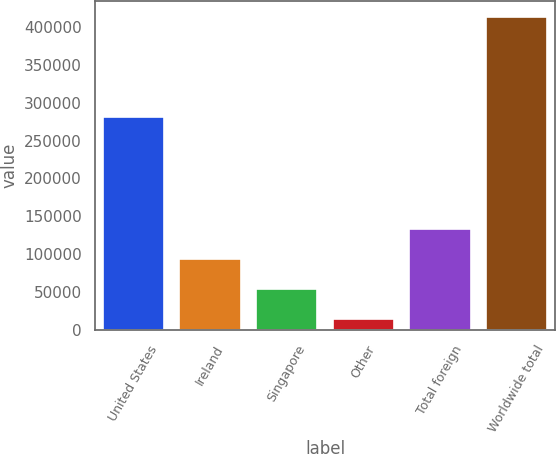<chart> <loc_0><loc_0><loc_500><loc_500><bar_chart><fcel>United States<fcel>Ireland<fcel>Singapore<fcel>Other<fcel>Total foreign<fcel>Worldwide total<nl><fcel>281517<fcel>93779.2<fcel>53872.1<fcel>13965<fcel>133686<fcel>413036<nl></chart> 